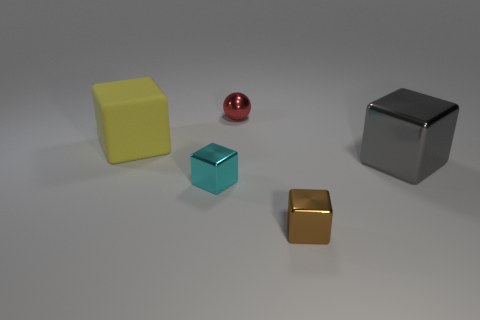Subtract all big gray shiny blocks. How many blocks are left? 3 Add 2 brown rubber balls. How many objects exist? 7 Subtract all spheres. How many objects are left? 4 Subtract all yellow cubes. How many cubes are left? 3 Add 5 large gray cubes. How many large gray cubes are left? 6 Add 1 yellow rubber things. How many yellow rubber things exist? 2 Subtract 0 blue cylinders. How many objects are left? 5 Subtract 3 cubes. How many cubes are left? 1 Subtract all yellow blocks. Subtract all cyan spheres. How many blocks are left? 3 Subtract all purple blocks. How many brown spheres are left? 0 